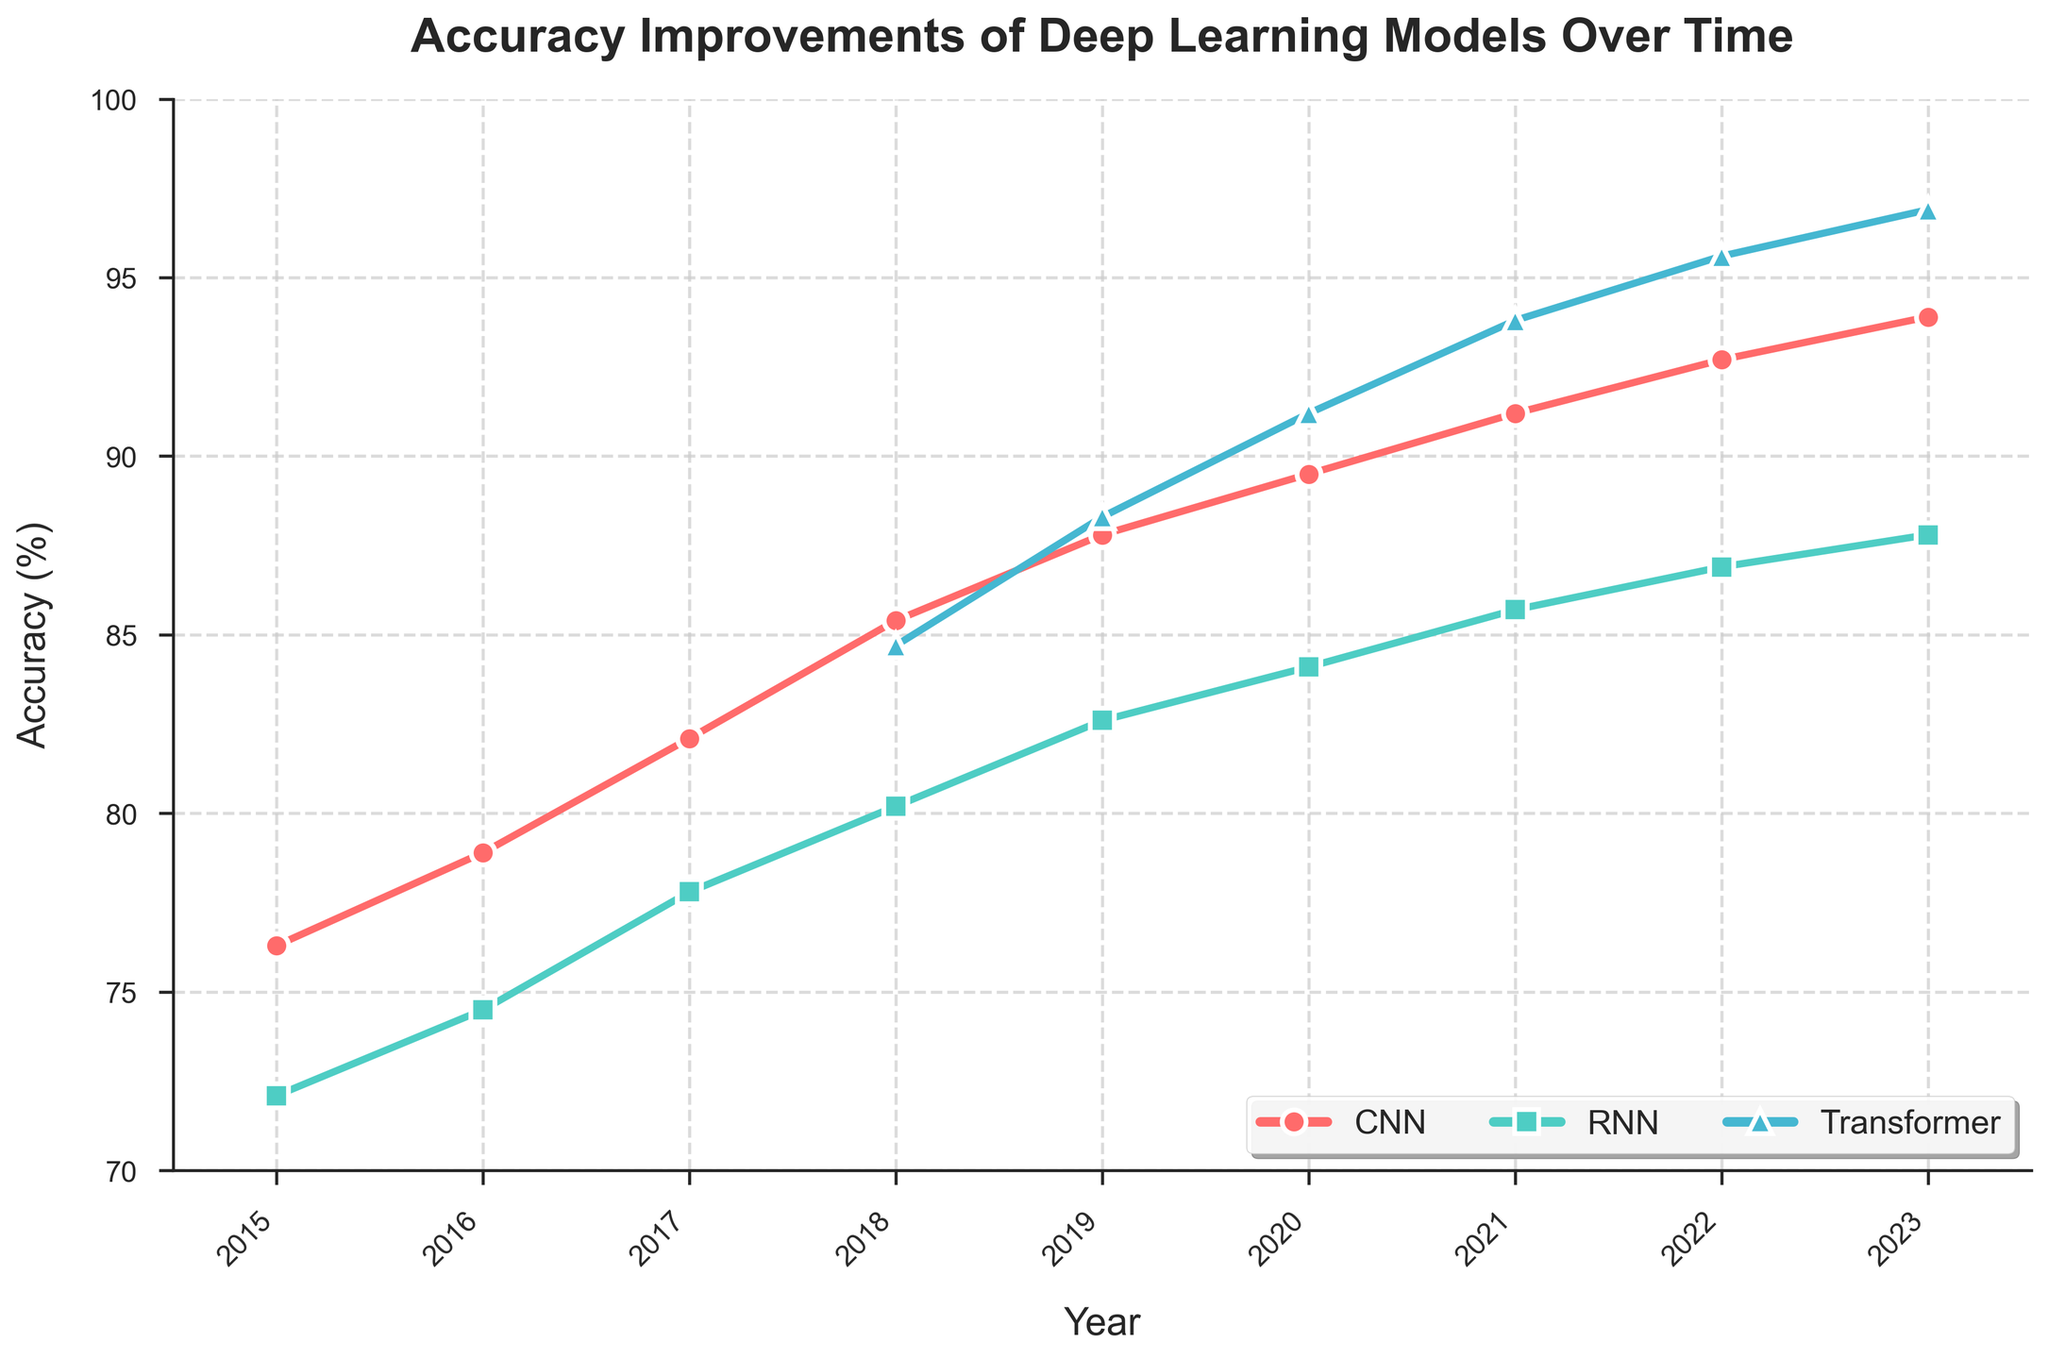What is the accuracy of the CNN architecture in 2020? Look at the point marked for CNN in 2020 on the x-axis, then find its corresponding value on the y-axis. The value is 89.5%.
Answer: 89.5% Which architecture had the highest accuracy in 2022? Check the points for CNN, RNN, and Transformer in the year 2022 and compare their y-values. The Transformer architecture reaches the highest point on the plot, indicating the highest accuracy of 95.6%.
Answer: Transformer In which year did the Transformer architecture surpass the CNN architecture? Compare the accuracy values of Transformer and CNN year by year. The Transformer first surpasses the CNN in 2019 with Transformer having 88.3% and CNN having 87.8%.
Answer: 2019 What is the average accuracy of the RNN architecture from 2015 to 2023? Sum the accuracy values for RNN from 2015 to 2023: 72.1 + 74.5 + 77.8 + 80.2 + 82.6 + 84.1 + 85.7 + 86.9 + 87.8 = 731.7. There are 9 years, so the average is 731.7/9 = 81.3%.
Answer: 81.3% By how many percentage points did the CNN architecture improve from 2015 to 2023? Subtract the 2015 value from the 2023 value for CNN: 93.9% - 76.3% = 17.6 percentage points.
Answer: 17.6 Which architecture showed the most significant improvement in accuracy from 2018 to 2023? Calculate the difference for each architecture from 2018 to 2023: 
- CNN: 93.9 - 85.4 = 8.5 
- RNN: 87.8 - 80.2 = 7.6 
- Transformer: 96.9 - 84.7 = 12.2 
The Transformer shows the most significant improvement of 12.2 percentage points.
Answer: Transformer What is the trend for the Transformer architecture's accuracy from 2018 to 2023? Observe the points for the Transformer from 2018 to 2023; the accuracy is increasing every year, indicating a consistent upward trend.
Answer: Upward trend How much higher was the accuracy of the Transformer architecture compared to the RNN architecture in 2021? Subtract the 2021 value for RNN from the 2021 value for Transformer: 93.8 - 85.7 = 8.1 percentage points.
Answer: 8.1 